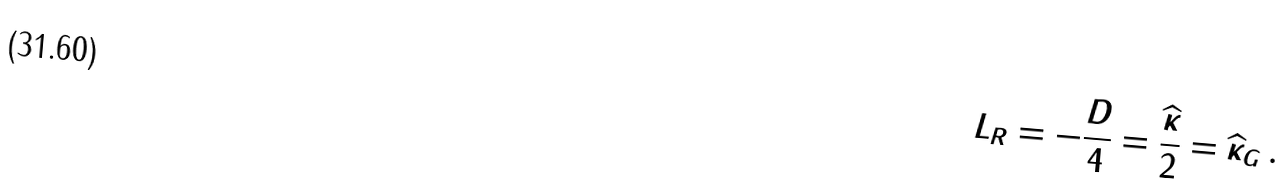Convert formula to latex. <formula><loc_0><loc_0><loc_500><loc_500>L _ { R } = - \frac { D } { 4 } = \frac { \widehat { \kappa } } { 2 } = \widehat { \kappa } _ { G } \, .</formula> 